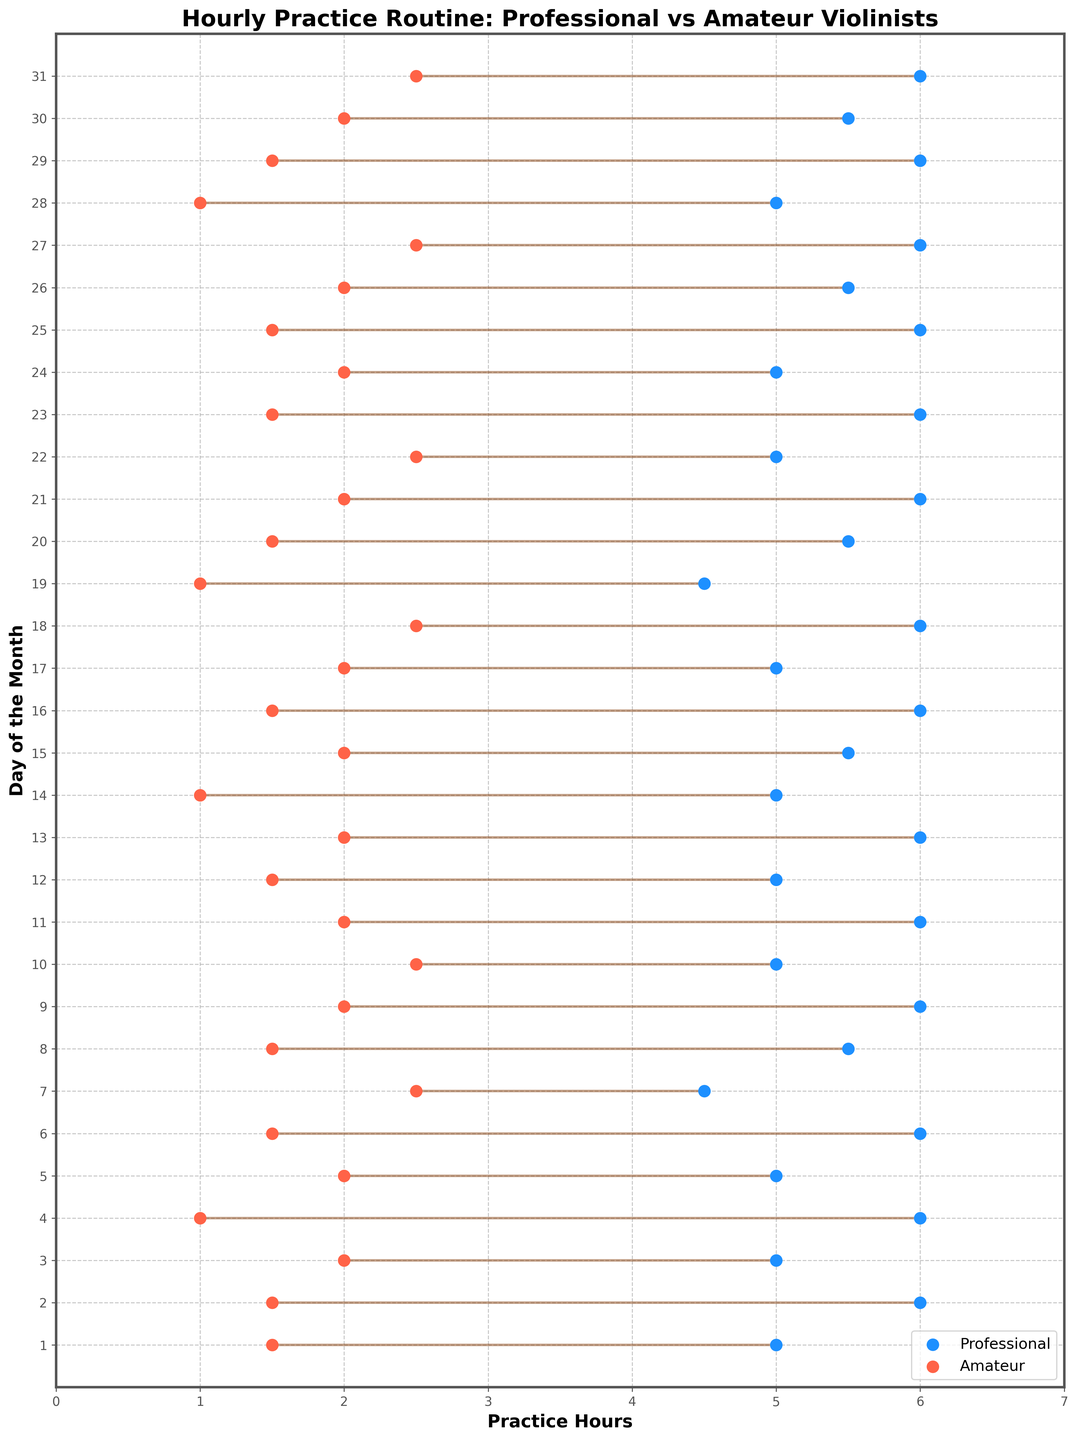What is the title of the plot? The title is written at the top of the plot and highlights the main subject of the data being displayed.
Answer: Hourly Practice Routine: Professional vs Amateur Violinists How many different days' data are illustrated in the plot? The y-axis displays the range of days, which can be counted by increments from the first to the last day of the month.
Answer: 31 What is the maximum practice hours for professional violinists? The blue dots representing professional violinists' hours peak at specific values on the x-axis. Locate the highest x-coordinate among blue dots.
Answer: 6 On which day did amateurs practice for 2.5 hours? Locate red dots on the plot, and find the ones which align with the 2.5-hour mark on the x-axis; then read off the corresponding day on the y-axis.
Answer: 7, 10, 18, 27, 31 How does the average practice time compare between professionals and amateurs? Calculate the mean of practice hours for each group by summing the hourly values and dividing by the number of days, then compare the results.
Answer: Professionals have a higher average On which day is the difference between professional and amateur practice hours the largest? Identify each vertical dumbbell line's length by comparing the distance between blue and red dots for each day and find the day with the maximum length.
Answer: 2023-10-04 What is the range of practice hours for amateurs? Identify the lowest and highest points for red dots on the x-axis, which represent amateurs' practice hours.
Answer: 1 to 2.5 What is the median practice time for amateurs? Arrange all the hourly practice times for amateur violinists in order and find the middle value. There are 31 data points, thus the 16th value is the median.
Answer: 1.5 On how many days did professionals practice less than 5.5 hours? Locate all blue dots where the x-coordinate is less than 5.5 and count the number of such occurrences.
Answer: 9 Which day shows equal practice hours between professionals and amateurs? Locate the horizontal line where both ends of the dumbbell have equal x-coordinates for blue and red dots.
Answer: There are no equal hours 